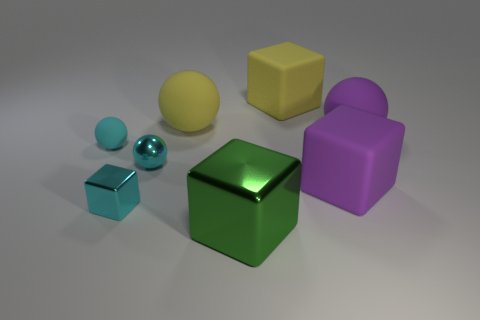Can you describe the shapes and colors of the objects depicted? Certainly! The image features an assortment of geometric shapes with various colors. Starting from the front, there's a small cyan cube, followed by a shiny teal sphere. Moving towards the center, we have a large metallic green cube. To the right of the green cube, there's a matte yellow cube and a small glossy purple sphere attached to a larger cube of the same color. To the left, we see a slightly reflective pastel yellow sphere. 